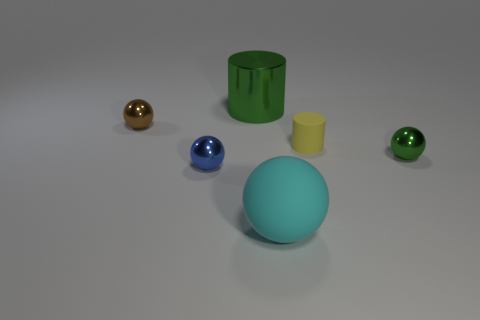How many matte objects are large green cylinders or tiny green cylinders?
Give a very brief answer. 0. There is a green object that is left of the tiny green shiny ball in front of the metallic cylinder; what shape is it?
Give a very brief answer. Cylinder. Are there fewer small cylinders on the left side of the tiny yellow cylinder than big red metal cylinders?
Give a very brief answer. No. What is the shape of the brown shiny object?
Offer a terse response. Sphere. There is a yellow rubber object on the right side of the cyan matte ball; how big is it?
Make the answer very short. Small. The metallic thing that is the same size as the cyan sphere is what color?
Your answer should be very brief. Green. Is there a thing that has the same color as the big shiny cylinder?
Give a very brief answer. Yes. Is the number of tiny brown metallic things right of the small brown ball less than the number of tiny blue spheres in front of the small matte cylinder?
Give a very brief answer. Yes. What is the material of the thing that is both on the left side of the rubber cylinder and right of the green shiny cylinder?
Give a very brief answer. Rubber. There is a yellow thing; is its shape the same as the thing behind the small brown metal thing?
Your response must be concise. Yes. 